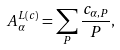Convert formula to latex. <formula><loc_0><loc_0><loc_500><loc_500>A _ { \alpha } ^ { L ( c ) } = \sum _ { P } \frac { c _ { \alpha , P } } { P } ,</formula> 